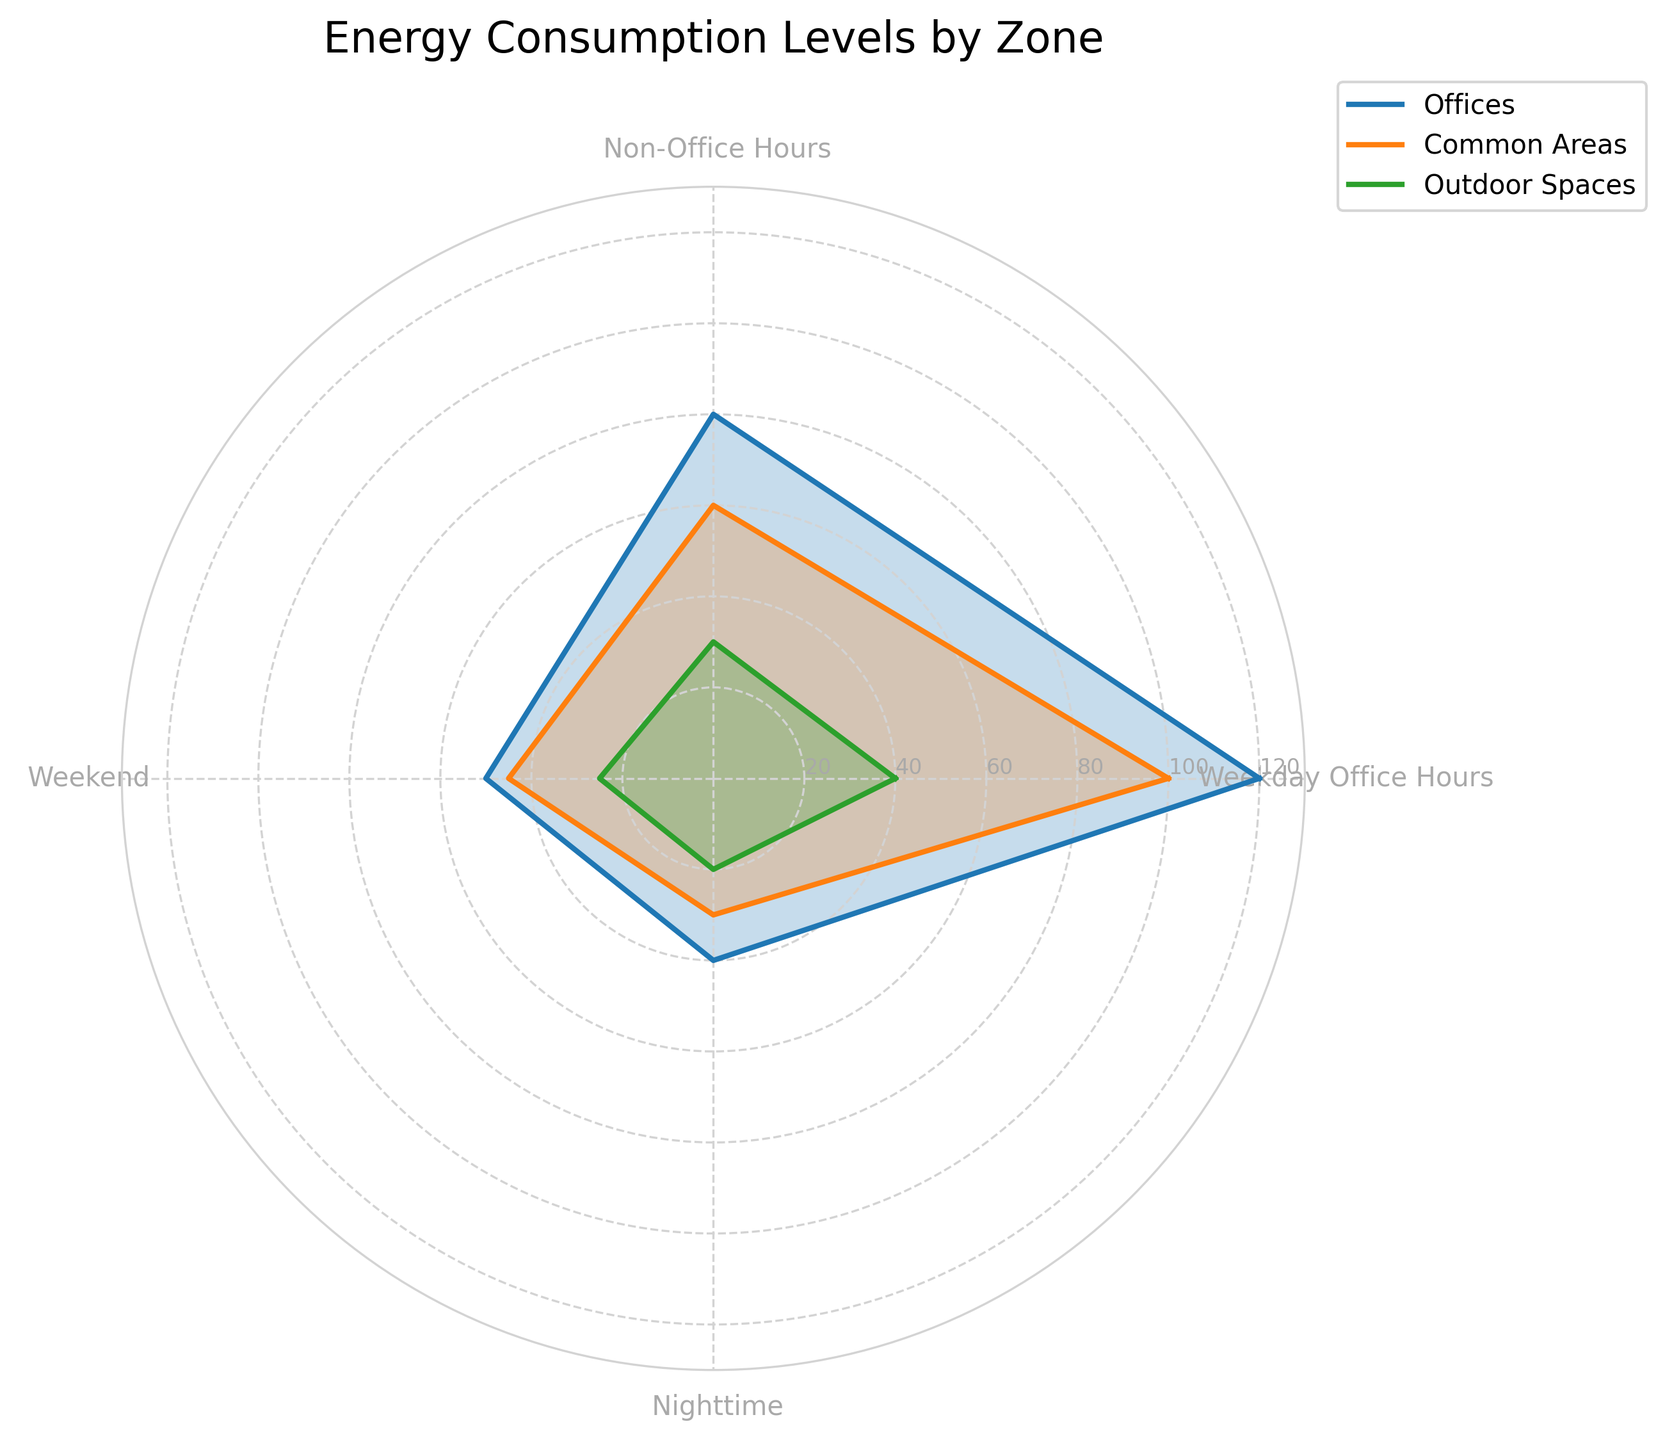What is the highest energy consumption level shown in the figure? The highest energy consumption level can be found by looking at the outermost value in the radar chart. In this case, the Offices zone during Weekday Office Hours has the highest level at 120.
Answer: 120 Which zone has the lowest energy consumption at Nighttime? To find the lowest energy consumption at Nighttime, we need to compare the values for all zones at that specific time. Offices have 40, Common Areas have 30, and Outdoor Spaces have 20. Thus, Outdoor Spaces have the lowest at 20.
Answer: Outdoor Spaces Between Common Areas and Outdoor Spaces, which zone has higher energy consumption during the Weekend? By comparing the Weekend values for both zones, Common Areas have 45 and Outdoor Spaces have 25. So, Common Areas have higher energy consumption during the Weekend.
Answer: Common Areas What is the average energy consumption level for Offices across all time periods? To calculate the average for Offices: (120 + 80 + 50 + 40) / 4 = 290 / 4 = 72.5
Answer: 72.5 How much more energy does Offices consume than Common Areas during Weekday Office Hours? Offices consume 120 and Common Areas consume 100 during Weekday Office Hours. The difference is 120 - 100 = 20.
Answer: 20 During Non-Office Hours, which zone has higher energy consumption, and by how much, compared to Outdoor Spaces? Non-Office Hours values are 80 for Offices, 60 for Common Areas, and 30 for Outdoor Spaces. Offices consume 50 more than Outdoor Spaces (80 - 30), and Common Areas consume 30 more than Outdoor Spaces (60 - 30).
Answer: Offices by 50, Common Areas by 30 What proportion of energy consumption does the Nighttime value of Offices represent out of its total consumption? The total for Offices is 120 + 80 + 50 + 40 = 290, and the Nighttime value is 40. The proportion is 40 / 290 ≈ 0.1379 or 13.79%.
Answer: 13.79% Which time period shows the smallest variation in energy consumption between all zones? The variations can be found by examining the differences for each period. Weekday Office Hours: (120-40) = 80, Non-Office Hours: (80-30) = 50, Weekend: (50-25) = 25, Nighttime: (40-20) = 20. The smallest variation is during Nighttime with a difference of 20.
Answer: Nighttime 